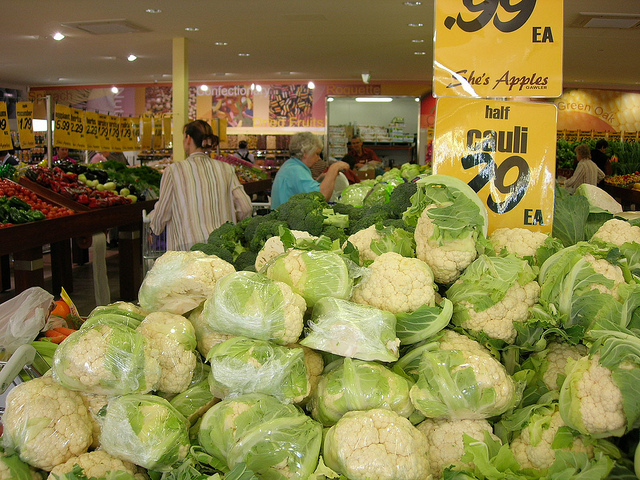Besides cauliflower, what other vegetables can you identify in the background? In the background, we can see an array of other vegetables such as green bell peppers and red tomatoes displayed in the market. 